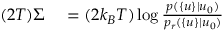Convert formula to latex. <formula><loc_0><loc_0><loc_500><loc_500>\begin{array} { r l } { ( 2 T ) \Sigma } & = ( 2 k _ { B } T ) \log \frac { p ( \{ u \} | u _ { 0 } ) } { p _ { r } ( \{ u \} | u _ { 0 } ) } } \end{array}</formula> 